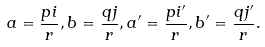<formula> <loc_0><loc_0><loc_500><loc_500>a = \frac { p i } { r } , b = \frac { q j } { r } , a ^ { \prime } = \frac { p i ^ { \prime } } { r } , b ^ { \prime } = \frac { q j ^ { \prime } } { r } .</formula> 